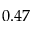<formula> <loc_0><loc_0><loc_500><loc_500>0 . 4 7</formula> 